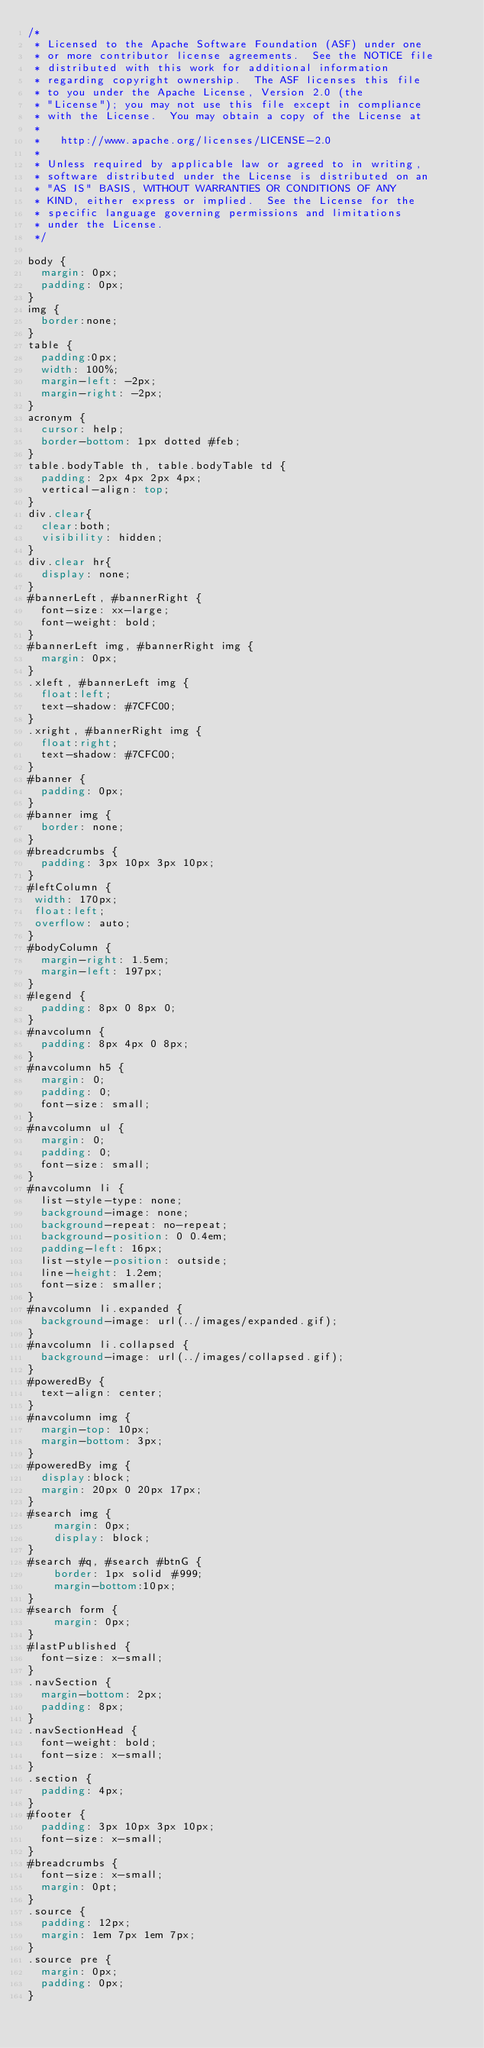<code> <loc_0><loc_0><loc_500><loc_500><_CSS_>/*
 * Licensed to the Apache Software Foundation (ASF) under one
 * or more contributor license agreements.  See the NOTICE file
 * distributed with this work for additional information
 * regarding copyright ownership.  The ASF licenses this file
 * to you under the Apache License, Version 2.0 (the
 * "License"); you may not use this file except in compliance
 * with the License.  You may obtain a copy of the License at
 *
 *   http://www.apache.org/licenses/LICENSE-2.0
 *
 * Unless required by applicable law or agreed to in writing,
 * software distributed under the License is distributed on an
 * "AS IS" BASIS, WITHOUT WARRANTIES OR CONDITIONS OF ANY
 * KIND, either express or implied.  See the License for the
 * specific language governing permissions and limitations
 * under the License.    
 */

body {
  margin: 0px;
  padding: 0px;
}
img {
  border:none;
}
table {
  padding:0px;
  width: 100%;
  margin-left: -2px;
  margin-right: -2px;
}
acronym {
  cursor: help;
  border-bottom: 1px dotted #feb;
}
table.bodyTable th, table.bodyTable td {
  padding: 2px 4px 2px 4px;
  vertical-align: top;
}
div.clear{
  clear:both;
  visibility: hidden;
}
div.clear hr{
  display: none;
}
#bannerLeft, #bannerRight {
  font-size: xx-large;
  font-weight: bold;
}
#bannerLeft img, #bannerRight img {
  margin: 0px;
}
.xleft, #bannerLeft img {
  float:left;
  text-shadow: #7CFC00;
}
.xright, #bannerRight img {
  float:right;
  text-shadow: #7CFC00;
}
#banner {
  padding: 0px;
}
#banner img {
  border: none;
}
#breadcrumbs {
  padding: 3px 10px 3px 10px;
}
#leftColumn {
 width: 170px;
 float:left;
 overflow: auto;
}
#bodyColumn {
  margin-right: 1.5em;
  margin-left: 197px;
}
#legend {
  padding: 8px 0 8px 0;
}
#navcolumn {
  padding: 8px 4px 0 8px;
}
#navcolumn h5 {
  margin: 0;
  padding: 0;
  font-size: small;
}
#navcolumn ul {
  margin: 0;
  padding: 0;
  font-size: small;
}
#navcolumn li {
  list-style-type: none;
  background-image: none;
  background-repeat: no-repeat;
  background-position: 0 0.4em;
  padding-left: 16px;
  list-style-position: outside;
  line-height: 1.2em;
  font-size: smaller;
}
#navcolumn li.expanded {
  background-image: url(../images/expanded.gif);
}
#navcolumn li.collapsed {
  background-image: url(../images/collapsed.gif);
}
#poweredBy {
  text-align: center;
}
#navcolumn img {
  margin-top: 10px;
  margin-bottom: 3px;
}
#poweredBy img {
  display:block;
  margin: 20px 0 20px 17px;
}
#search img {
    margin: 0px;
    display: block;
}
#search #q, #search #btnG {
    border: 1px solid #999;
    margin-bottom:10px;
}
#search form {
    margin: 0px;
}
#lastPublished {
  font-size: x-small;
}
.navSection {
  margin-bottom: 2px;
  padding: 8px;
}
.navSectionHead {
  font-weight: bold;
  font-size: x-small;
}
.section {
  padding: 4px;
}
#footer {
  padding: 3px 10px 3px 10px;
  font-size: x-small;
}
#breadcrumbs {
  font-size: x-small;
  margin: 0pt;
}
.source {
  padding: 12px;
  margin: 1em 7px 1em 7px;
}
.source pre {
  margin: 0px;
  padding: 0px;
}
</code> 